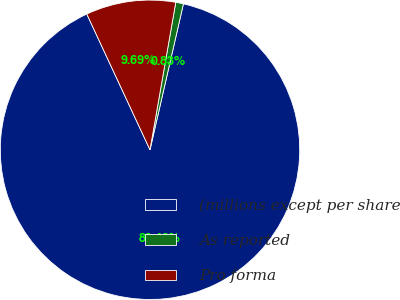<chart> <loc_0><loc_0><loc_500><loc_500><pie_chart><fcel>(millions except per share<fcel>As reported<fcel>Pro forma<nl><fcel>89.48%<fcel>0.83%<fcel>9.69%<nl></chart> 